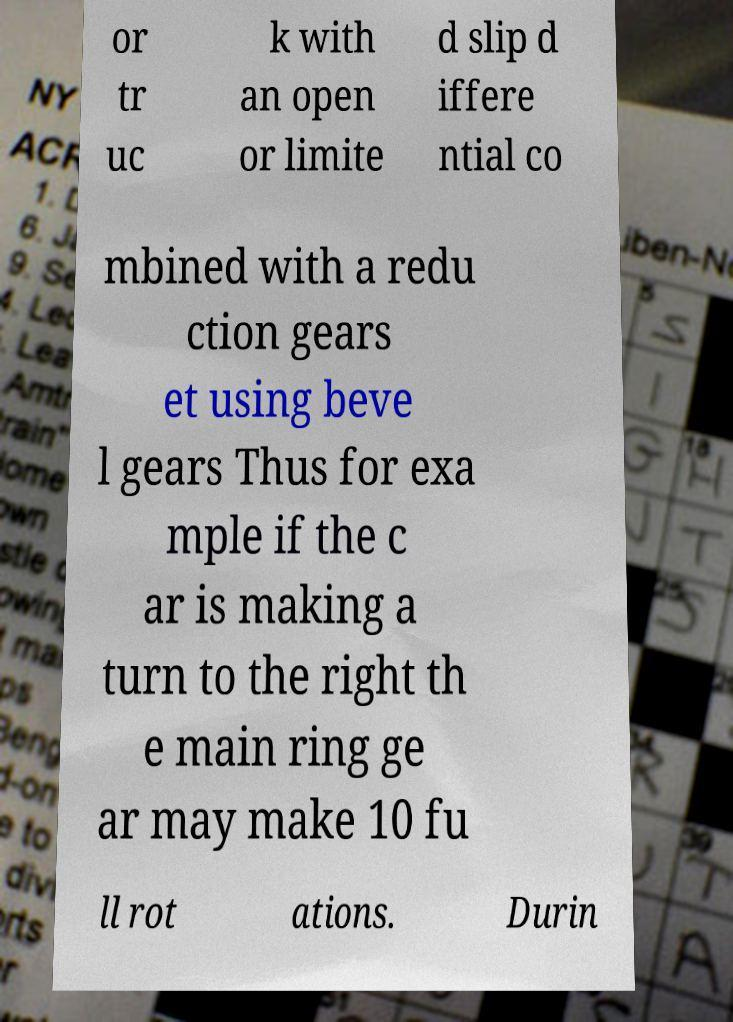What messages or text are displayed in this image? I need them in a readable, typed format. or tr uc k with an open or limite d slip d iffere ntial co mbined with a redu ction gears et using beve l gears Thus for exa mple if the c ar is making a turn to the right th e main ring ge ar may make 10 fu ll rot ations. Durin 